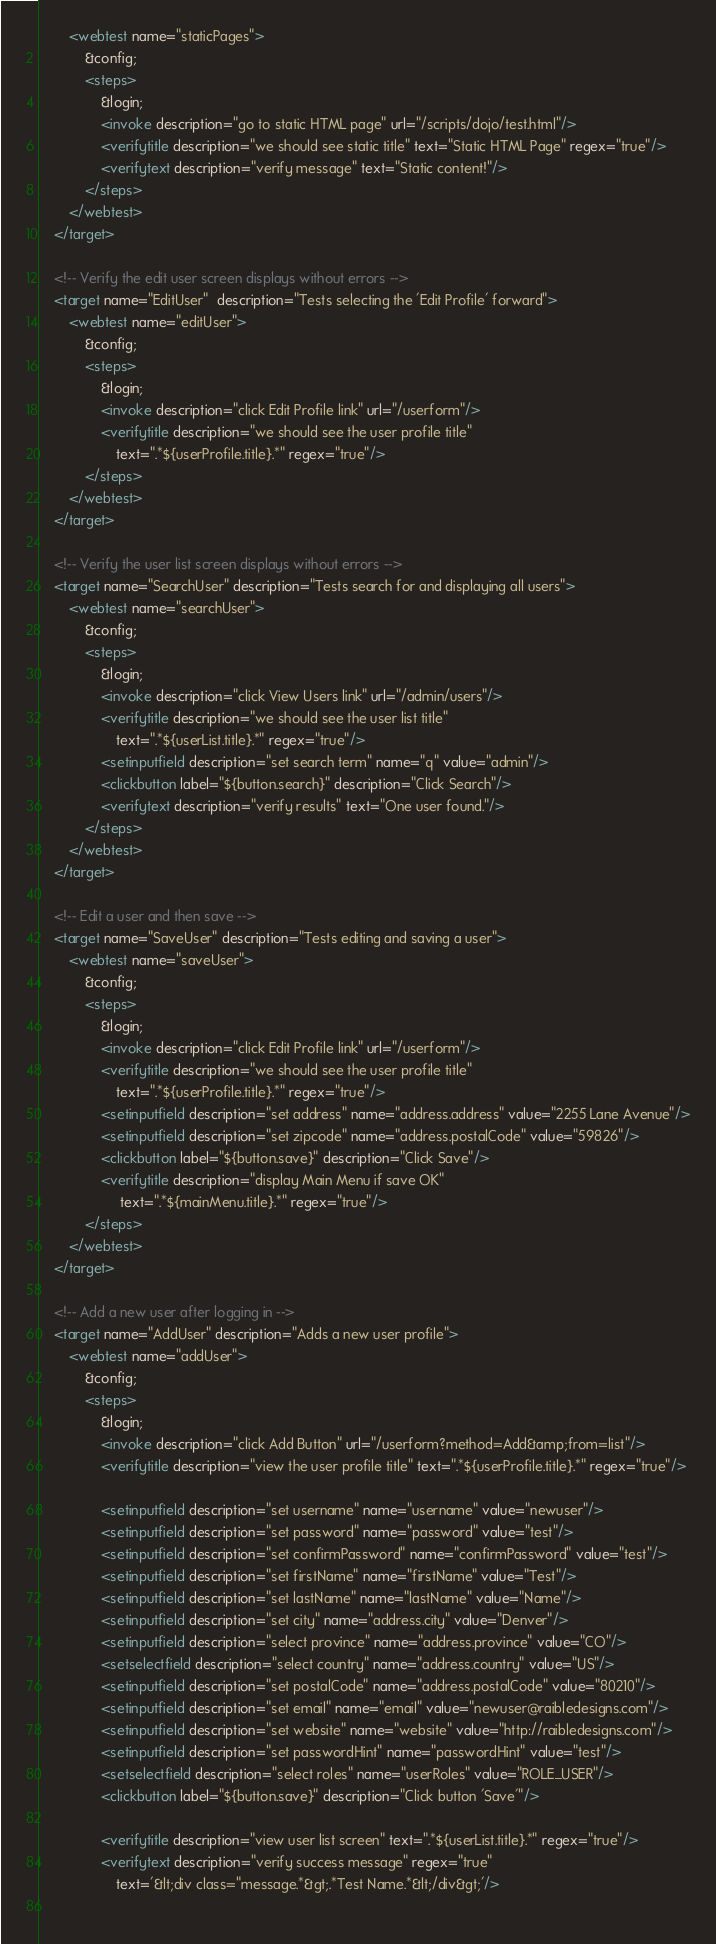Convert code to text. <code><loc_0><loc_0><loc_500><loc_500><_XML_>        <webtest name="staticPages">
            &config;
            <steps>
                &login;
                <invoke description="go to static HTML page" url="/scripts/dojo/test.html"/>
                <verifytitle description="we should see static title" text="Static HTML Page" regex="true"/>
                <verifytext description="verify message" text="Static content!"/>
            </steps>
        </webtest>
    </target>

    <!-- Verify the edit user screen displays without errors -->
    <target name="EditUser"  description="Tests selecting the 'Edit Profile' forward">
        <webtest name="editUser">
            &config;
            <steps>
                &login;
                <invoke description="click Edit Profile link" url="/userform"/>
                <verifytitle description="we should see the user profile title" 
                    text=".*${userProfile.title}.*" regex="true"/>
            </steps>
        </webtest>
    </target>
    
    <!-- Verify the user list screen displays without errors -->
    <target name="SearchUser" description="Tests search for and displaying all users">
        <webtest name="searchUser">
            &config;
            <steps>
                &login;
                <invoke description="click View Users link" url="/admin/users"/>
                <verifytitle description="we should see the user list title" 
                    text=".*${userList.title}.*" regex="true"/>
                <setinputfield description="set search term" name="q" value="admin"/>
                <clickbutton label="${button.search}" description="Click Search"/>
                <verifytext description="verify results" text="One user found."/>
            </steps>
        </webtest>
    </target>
    
    <!-- Edit a user and then save -->
    <target name="SaveUser" description="Tests editing and saving a user">
        <webtest name="saveUser">
            &config;
            <steps>
                &login;
                <invoke description="click Edit Profile link" url="/userform"/>
                <verifytitle description="we should see the user profile title" 
                    text=".*${userProfile.title}.*" regex="true"/>
                <setinputfield description="set address" name="address.address" value="2255 Lane Avenue"/>
                <setinputfield description="set zipcode" name="address.postalCode" value="59826"/>
                <clickbutton label="${button.save}" description="Click Save"/>
                <verifytitle description="display Main Menu if save OK"
                     text=".*${mainMenu.title}.*" regex="true"/>
            </steps>
        </webtest>
    </target>
    
    <!-- Add a new user after logging in -->
    <target name="AddUser" description="Adds a new user profile">
        <webtest name="addUser">
            &config;
            <steps>
                &login;
                <invoke description="click Add Button" url="/userform?method=Add&amp;from=list"/>
                <verifytitle description="view the user profile title" text=".*${userProfile.title}.*" regex="true"/>
                    
                <setinputfield description="set username" name="username" value="newuser"/>
                <setinputfield description="set password" name="password" value="test"/>
                <setinputfield description="set confirmPassword" name="confirmPassword" value="test"/>
                <setinputfield description="set firstName" name="firstName" value="Test"/>
                <setinputfield description="set lastName" name="lastName" value="Name"/>
                <setinputfield description="set city" name="address.city" value="Denver"/>
                <setinputfield description="select province" name="address.province" value="CO"/>
                <setselectfield description="select country" name="address.country" value="US"/>
                <setinputfield description="set postalCode" name="address.postalCode" value="80210"/>
                <setinputfield description="set email" name="email" value="newuser@raibledesigns.com"/>
                <setinputfield description="set website" name="website" value="http://raibledesigns.com"/>
                <setinputfield description="set passwordHint" name="passwordHint" value="test"/>
                <setselectfield description="select roles" name="userRoles" value="ROLE_USER"/>
                <clickbutton label="${button.save}" description="Click button 'Save'"/>

                <verifytitle description="view user list screen" text=".*${userList.title}.*" regex="true"/>
                <verifytext description="verify success message" regex="true"
                    text='&lt;div class="message.*&gt;.*Test Name.*&lt;/div&gt;'/>
                    </code> 